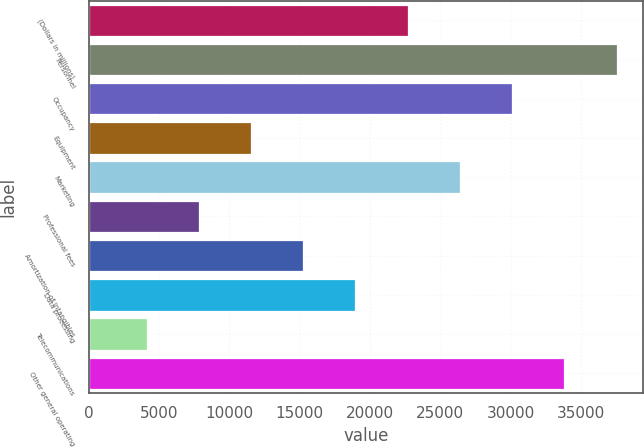Convert chart. <chart><loc_0><loc_0><loc_500><loc_500><bar_chart><fcel>(Dollars in millions)<fcel>Personnel<fcel>Occupancy<fcel>Equipment<fcel>Marketing<fcel>Professional fees<fcel>Amortization of intangibles<fcel>Data processing<fcel>Telecommunications<fcel>Other general operating<nl><fcel>22678.4<fcel>37524<fcel>30101.2<fcel>11544.2<fcel>26389.8<fcel>7832.8<fcel>15255.6<fcel>18967<fcel>4121.4<fcel>33812.6<nl></chart> 